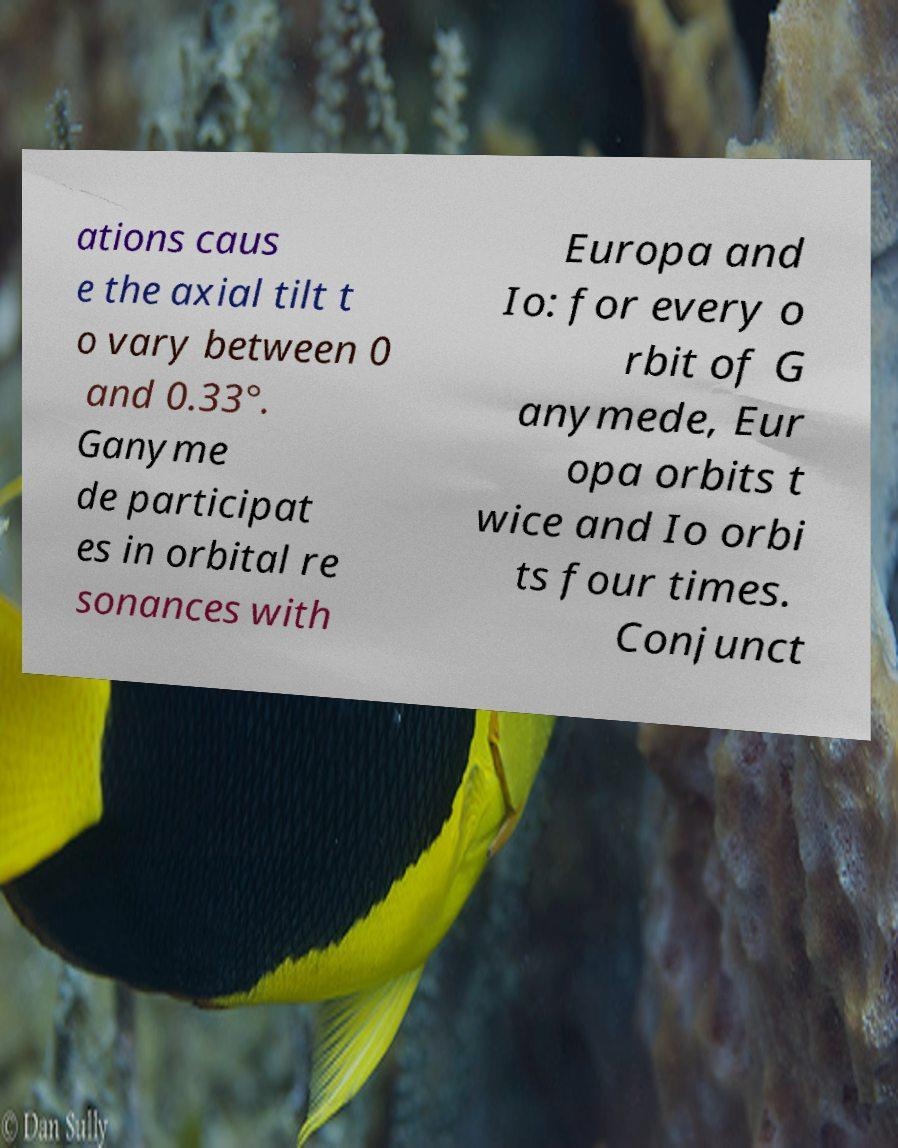Please identify and transcribe the text found in this image. ations caus e the axial tilt t o vary between 0 and 0.33°. Ganyme de participat es in orbital re sonances with Europa and Io: for every o rbit of G anymede, Eur opa orbits t wice and Io orbi ts four times. Conjunct 